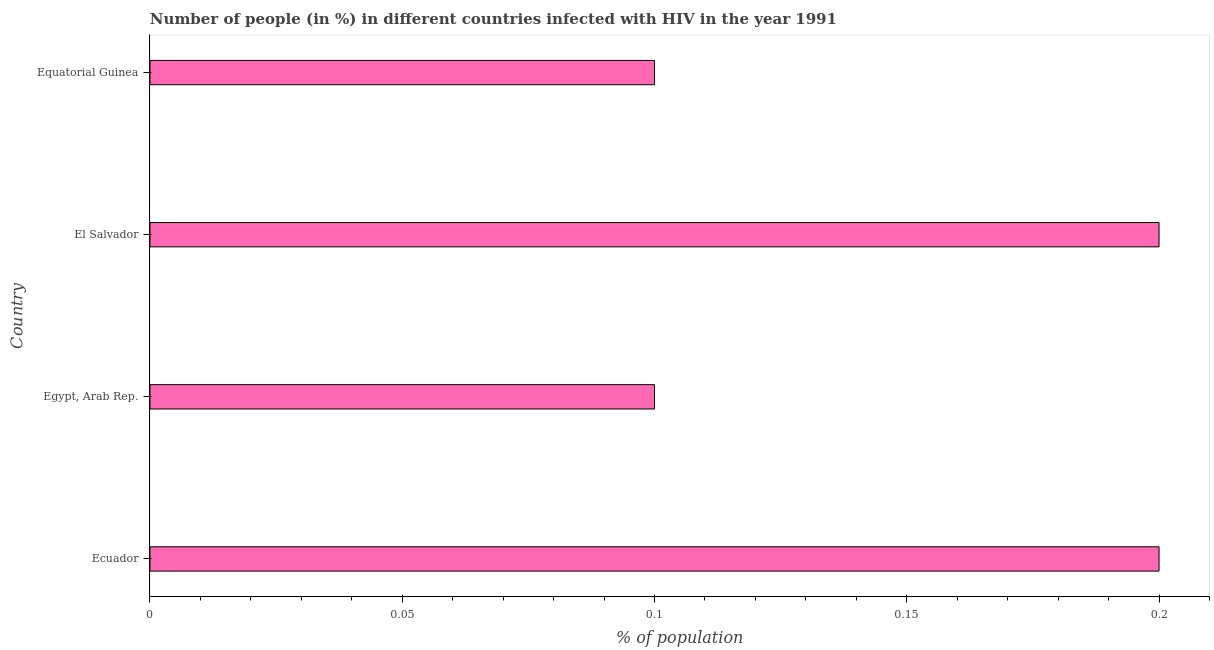Does the graph contain any zero values?
Offer a terse response. No. Does the graph contain grids?
Make the answer very short. No. What is the title of the graph?
Provide a short and direct response. Number of people (in %) in different countries infected with HIV in the year 1991. What is the label or title of the X-axis?
Your answer should be compact. % of population. In which country was the number of people infected with hiv maximum?
Offer a terse response. Ecuador. In which country was the number of people infected with hiv minimum?
Provide a succinct answer. Egypt, Arab Rep. What is the sum of the number of people infected with hiv?
Make the answer very short. 0.6. What is the difference between the number of people infected with hiv in Ecuador and Egypt, Arab Rep.?
Provide a short and direct response. 0.1. What is the median number of people infected with hiv?
Provide a short and direct response. 0.15. In how many countries, is the number of people infected with hiv greater than 0.11 %?
Your answer should be very brief. 2. Is the difference between the number of people infected with hiv in Egypt, Arab Rep. and El Salvador greater than the difference between any two countries?
Provide a succinct answer. Yes. What is the difference between the highest and the second highest number of people infected with hiv?
Your answer should be very brief. 0. Is the sum of the number of people infected with hiv in Ecuador and Egypt, Arab Rep. greater than the maximum number of people infected with hiv across all countries?
Offer a terse response. Yes. What is the difference between two consecutive major ticks on the X-axis?
Provide a short and direct response. 0.05. What is the % of population in Ecuador?
Offer a terse response. 0.2. What is the % of population of El Salvador?
Provide a short and direct response. 0.2. What is the % of population of Equatorial Guinea?
Provide a short and direct response. 0.1. What is the difference between the % of population in Ecuador and Egypt, Arab Rep.?
Keep it short and to the point. 0.1. What is the difference between the % of population in Egypt, Arab Rep. and El Salvador?
Keep it short and to the point. -0.1. What is the difference between the % of population in El Salvador and Equatorial Guinea?
Your response must be concise. 0.1. What is the ratio of the % of population in Ecuador to that in Equatorial Guinea?
Your response must be concise. 2. What is the ratio of the % of population in Egypt, Arab Rep. to that in El Salvador?
Provide a succinct answer. 0.5. What is the ratio of the % of population in El Salvador to that in Equatorial Guinea?
Your response must be concise. 2. 